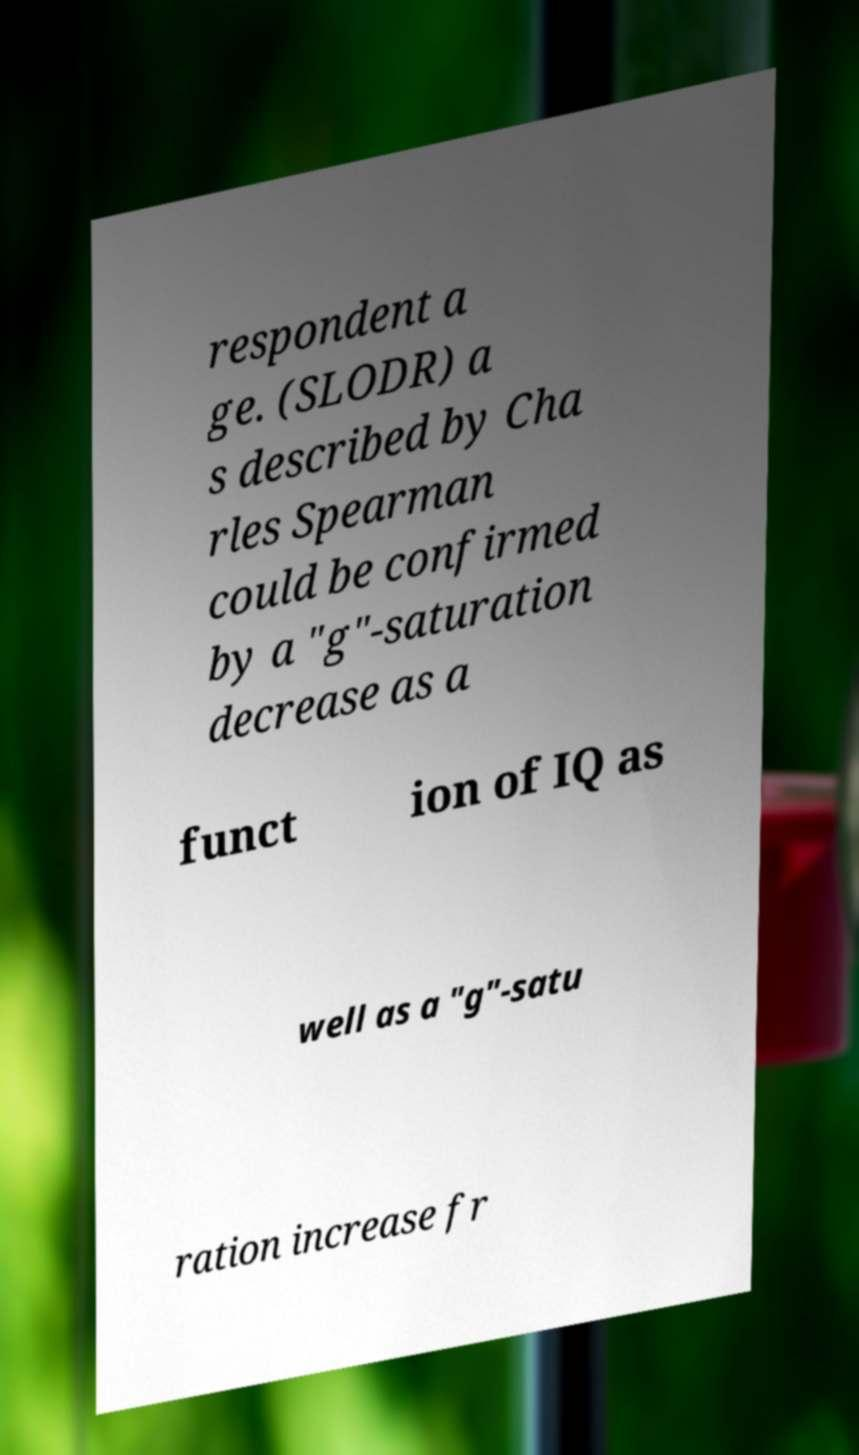What messages or text are displayed in this image? I need them in a readable, typed format. respondent a ge. (SLODR) a s described by Cha rles Spearman could be confirmed by a "g"-saturation decrease as a funct ion of IQ as well as a "g"-satu ration increase fr 